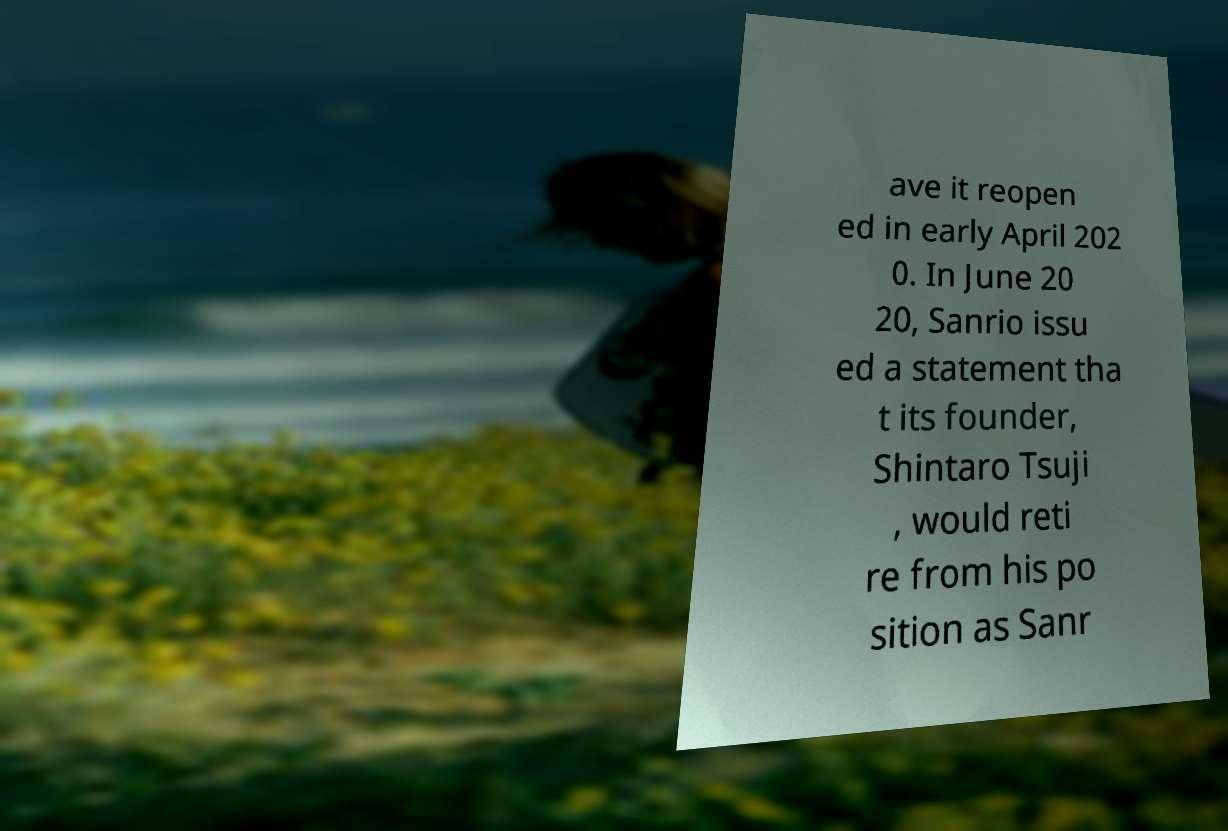For documentation purposes, I need the text within this image transcribed. Could you provide that? ave it reopen ed in early April 202 0. In June 20 20, Sanrio issu ed a statement tha t its founder, Shintaro Tsuji , would reti re from his po sition as Sanr 